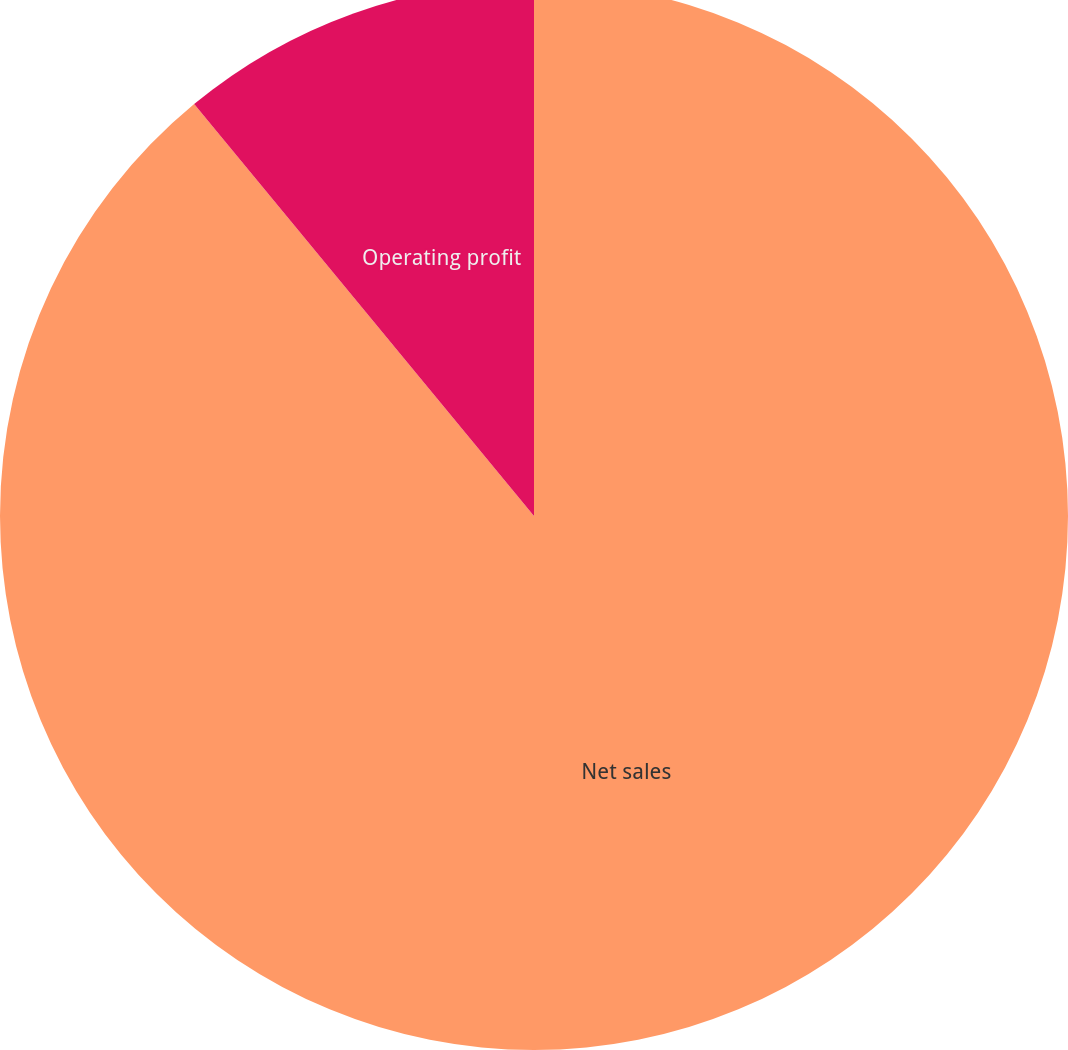Convert chart to OTSL. <chart><loc_0><loc_0><loc_500><loc_500><pie_chart><fcel>Net sales<fcel>Operating profit<nl><fcel>89.02%<fcel>10.98%<nl></chart> 